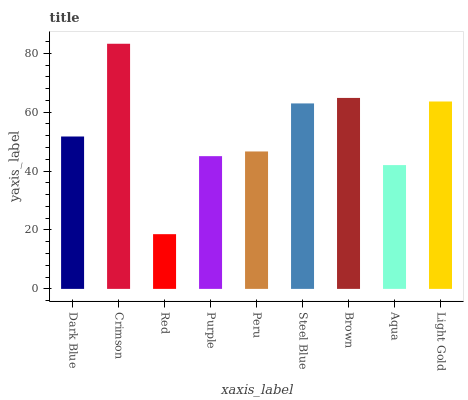Is Red the minimum?
Answer yes or no. Yes. Is Crimson the maximum?
Answer yes or no. Yes. Is Crimson the minimum?
Answer yes or no. No. Is Red the maximum?
Answer yes or no. No. Is Crimson greater than Red?
Answer yes or no. Yes. Is Red less than Crimson?
Answer yes or no. Yes. Is Red greater than Crimson?
Answer yes or no. No. Is Crimson less than Red?
Answer yes or no. No. Is Dark Blue the high median?
Answer yes or no. Yes. Is Dark Blue the low median?
Answer yes or no. Yes. Is Light Gold the high median?
Answer yes or no. No. Is Steel Blue the low median?
Answer yes or no. No. 